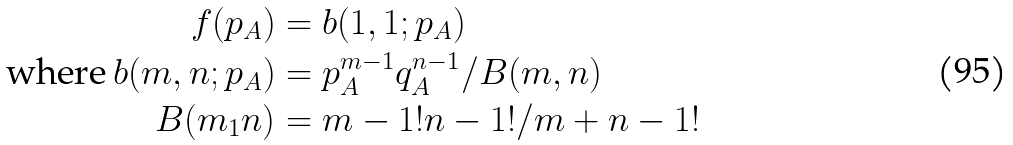<formula> <loc_0><loc_0><loc_500><loc_500>f ( p _ { A } ) & = b ( 1 , 1 ; p _ { A } ) \\ \text {where} \, b ( m , n ; p _ { A } ) & = p _ { A } ^ { m - 1 } q _ { A } ^ { n - 1 } / B ( m , n ) \\ B ( m _ { 1 } n ) & = m - 1 ! n - 1 ! / m + n - 1 ! \\</formula> 